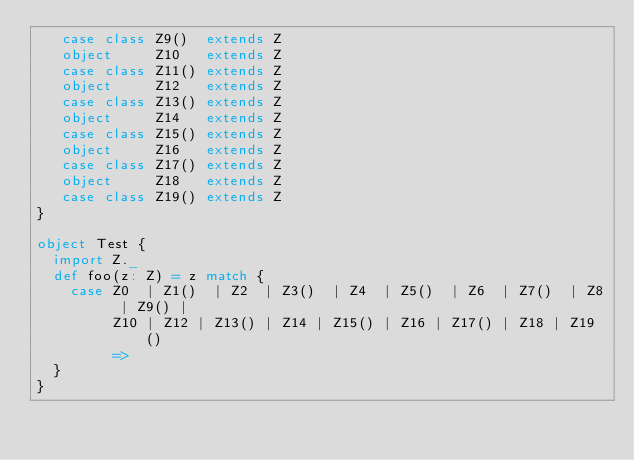<code> <loc_0><loc_0><loc_500><loc_500><_Scala_>   case class Z9()  extends Z
   object     Z10   extends Z
   case class Z11() extends Z
   object     Z12   extends Z
   case class Z13() extends Z
   object     Z14   extends Z
   case class Z15() extends Z
   object     Z16   extends Z
   case class Z17() extends Z
   object     Z18   extends Z
   case class Z19() extends Z
}

object Test {
  import Z._
  def foo(z: Z) = z match {
    case Z0  | Z1()  | Z2  | Z3()  | Z4  | Z5()  | Z6  | Z7()  | Z8  | Z9() |
         Z10 | Z12 | Z13() | Z14 | Z15() | Z16 | Z17() | Z18 | Z19()
         =>
  }
}
</code> 